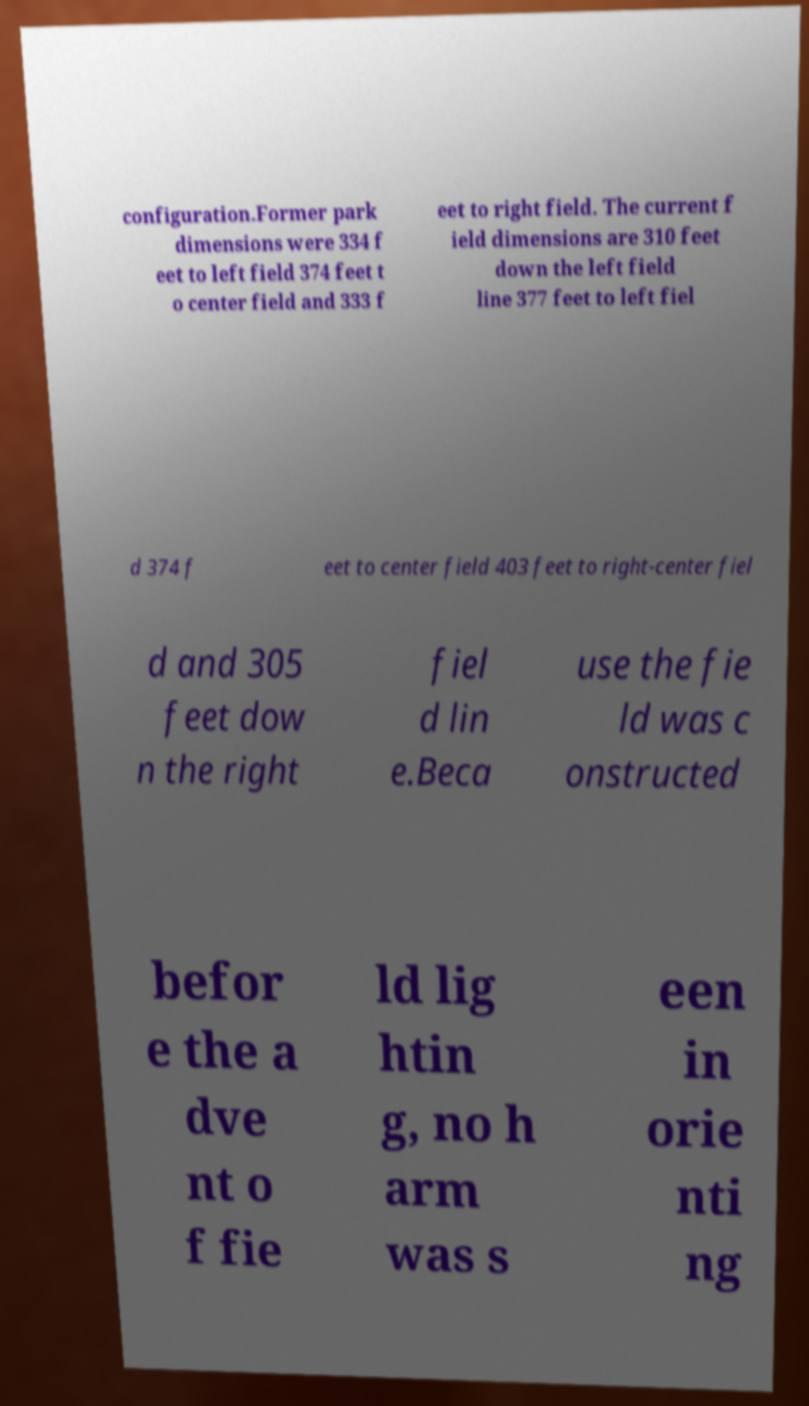What messages or text are displayed in this image? I need them in a readable, typed format. configuration.Former park dimensions were 334 f eet to left field 374 feet t o center field and 333 f eet to right field. The current f ield dimensions are 310 feet down the left field line 377 feet to left fiel d 374 f eet to center field 403 feet to right-center fiel d and 305 feet dow n the right fiel d lin e.Beca use the fie ld was c onstructed befor e the a dve nt o f fie ld lig htin g, no h arm was s een in orie nti ng 